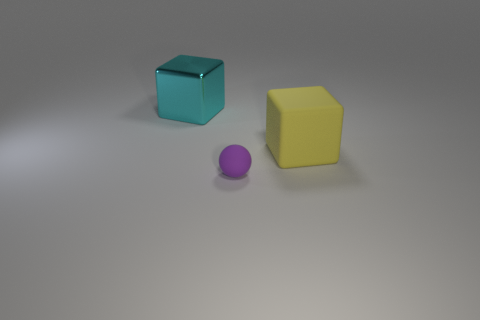Is there anything else that has the same size as the purple rubber ball?
Your answer should be very brief. No. Is the big yellow thing the same shape as the small matte thing?
Offer a terse response. No. What number of balls are either large yellow things or big shiny things?
Your answer should be very brief. 0. There is a tiny ball that is the same material as the yellow thing; what is its color?
Your response must be concise. Purple. There is a block to the right of the cyan metal block; is its size the same as the tiny purple matte ball?
Your answer should be very brief. No. Are the tiny purple sphere and the large cube on the left side of the large matte thing made of the same material?
Provide a short and direct response. No. There is a object that is on the left side of the sphere; what color is it?
Ensure brevity in your answer.  Cyan. There is a object in front of the large yellow thing; are there any balls behind it?
Provide a succinct answer. No. There is a metallic thing that is on the left side of the small purple rubber object; is it the same color as the thing in front of the large matte thing?
Provide a succinct answer. No. What number of tiny purple matte things are to the left of the tiny purple thing?
Offer a very short reply. 0. 